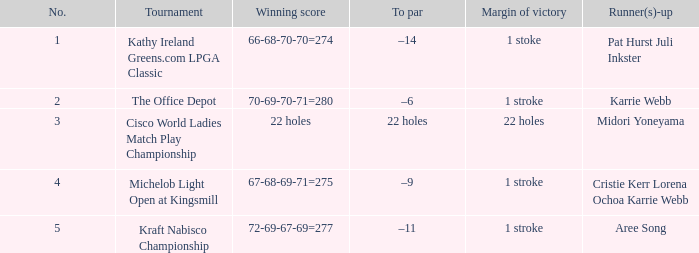Where was the tournament dated nov 3, 2002? Cisco World Ladies Match Play Championship. 